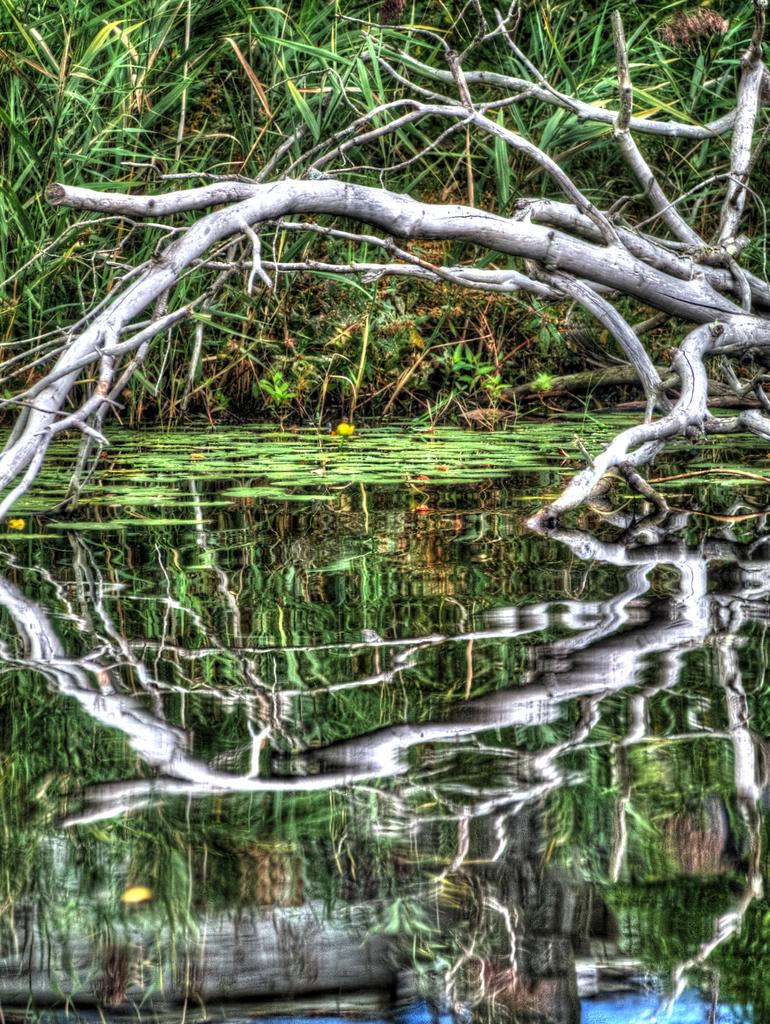What is the primary element in the image? There is water in the image. What can be seen partially submerged in the water? There is a dried tree stem in the water. What type of vegetation is visible in the image? There are grass plants visible in the image. What type of pickle is floating on the water in the image? There is no pickle present in the image; it only features water, a dried tree stem, and grass plants. 